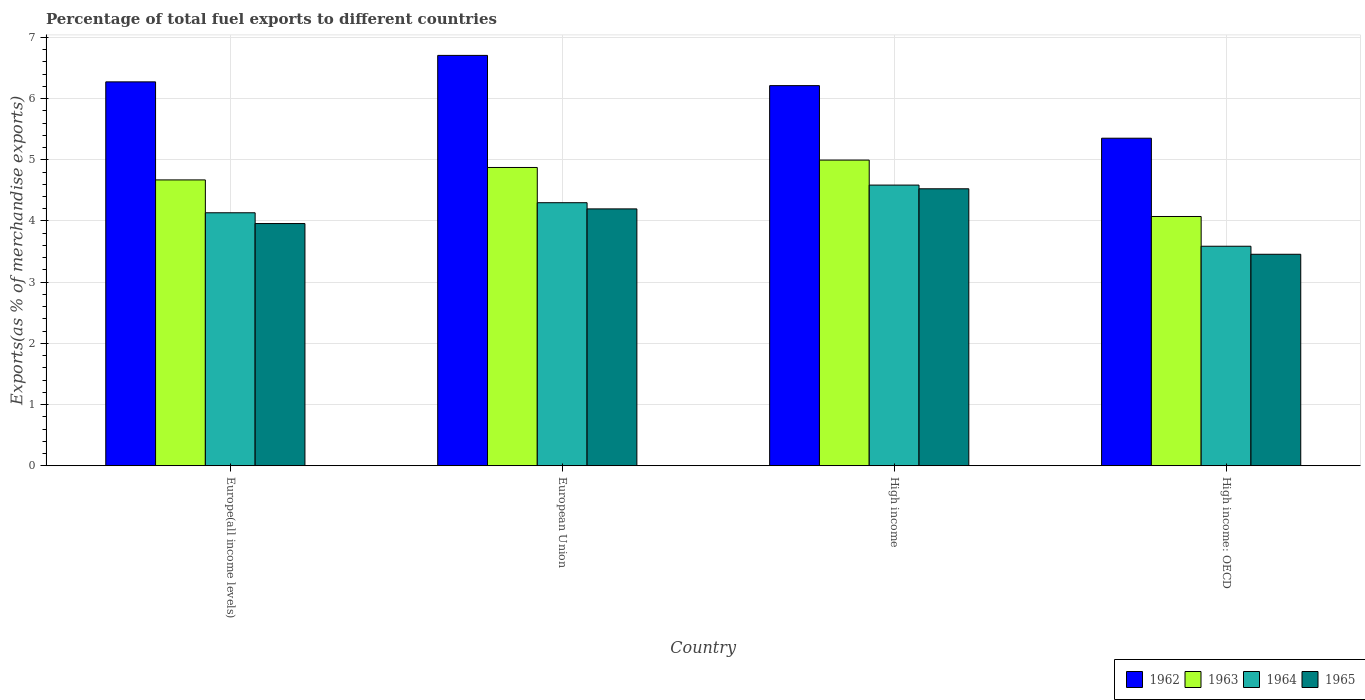What is the label of the 3rd group of bars from the left?
Offer a very short reply. High income. What is the percentage of exports to different countries in 1964 in Europe(all income levels)?
Your response must be concise. 4.13. Across all countries, what is the maximum percentage of exports to different countries in 1962?
Give a very brief answer. 6.71. Across all countries, what is the minimum percentage of exports to different countries in 1963?
Keep it short and to the point. 4.07. In which country was the percentage of exports to different countries in 1963 minimum?
Keep it short and to the point. High income: OECD. What is the total percentage of exports to different countries in 1962 in the graph?
Your response must be concise. 24.54. What is the difference between the percentage of exports to different countries in 1965 in Europe(all income levels) and that in High income: OECD?
Keep it short and to the point. 0.5. What is the difference between the percentage of exports to different countries in 1964 in High income and the percentage of exports to different countries in 1962 in European Union?
Offer a terse response. -2.12. What is the average percentage of exports to different countries in 1965 per country?
Ensure brevity in your answer.  4.03. What is the difference between the percentage of exports to different countries of/in 1964 and percentage of exports to different countries of/in 1965 in High income?
Your answer should be compact. 0.06. In how many countries, is the percentage of exports to different countries in 1962 greater than 2.8 %?
Make the answer very short. 4. What is the ratio of the percentage of exports to different countries in 1964 in High income to that in High income: OECD?
Your answer should be very brief. 1.28. What is the difference between the highest and the second highest percentage of exports to different countries in 1963?
Your response must be concise. -0.32. What is the difference between the highest and the lowest percentage of exports to different countries in 1962?
Ensure brevity in your answer.  1.35. Is the sum of the percentage of exports to different countries in 1965 in European Union and High income greater than the maximum percentage of exports to different countries in 1964 across all countries?
Make the answer very short. Yes. What does the 2nd bar from the left in High income: OECD represents?
Give a very brief answer. 1963. What does the 2nd bar from the right in High income represents?
Keep it short and to the point. 1964. Is it the case that in every country, the sum of the percentage of exports to different countries in 1963 and percentage of exports to different countries in 1962 is greater than the percentage of exports to different countries in 1964?
Provide a short and direct response. Yes. Are all the bars in the graph horizontal?
Your response must be concise. No. How many countries are there in the graph?
Provide a short and direct response. 4. Does the graph contain any zero values?
Offer a terse response. No. Does the graph contain grids?
Ensure brevity in your answer.  Yes. How many legend labels are there?
Provide a short and direct response. 4. What is the title of the graph?
Your response must be concise. Percentage of total fuel exports to different countries. What is the label or title of the X-axis?
Make the answer very short. Country. What is the label or title of the Y-axis?
Your answer should be compact. Exports(as % of merchandise exports). What is the Exports(as % of merchandise exports) of 1962 in Europe(all income levels)?
Your answer should be compact. 6.27. What is the Exports(as % of merchandise exports) in 1963 in Europe(all income levels)?
Make the answer very short. 4.67. What is the Exports(as % of merchandise exports) of 1964 in Europe(all income levels)?
Provide a succinct answer. 4.13. What is the Exports(as % of merchandise exports) in 1965 in Europe(all income levels)?
Your response must be concise. 3.96. What is the Exports(as % of merchandise exports) of 1962 in European Union?
Ensure brevity in your answer.  6.71. What is the Exports(as % of merchandise exports) of 1963 in European Union?
Give a very brief answer. 4.87. What is the Exports(as % of merchandise exports) in 1964 in European Union?
Give a very brief answer. 4.3. What is the Exports(as % of merchandise exports) of 1965 in European Union?
Offer a terse response. 4.2. What is the Exports(as % of merchandise exports) in 1962 in High income?
Your answer should be compact. 6.21. What is the Exports(as % of merchandise exports) in 1963 in High income?
Make the answer very short. 5. What is the Exports(as % of merchandise exports) of 1964 in High income?
Give a very brief answer. 4.59. What is the Exports(as % of merchandise exports) of 1965 in High income?
Give a very brief answer. 4.53. What is the Exports(as % of merchandise exports) in 1962 in High income: OECD?
Provide a succinct answer. 5.35. What is the Exports(as % of merchandise exports) in 1963 in High income: OECD?
Make the answer very short. 4.07. What is the Exports(as % of merchandise exports) of 1964 in High income: OECD?
Your answer should be very brief. 3.59. What is the Exports(as % of merchandise exports) of 1965 in High income: OECD?
Your response must be concise. 3.46. Across all countries, what is the maximum Exports(as % of merchandise exports) in 1962?
Your answer should be very brief. 6.71. Across all countries, what is the maximum Exports(as % of merchandise exports) in 1963?
Give a very brief answer. 5. Across all countries, what is the maximum Exports(as % of merchandise exports) in 1964?
Your answer should be very brief. 4.59. Across all countries, what is the maximum Exports(as % of merchandise exports) of 1965?
Keep it short and to the point. 4.53. Across all countries, what is the minimum Exports(as % of merchandise exports) of 1962?
Make the answer very short. 5.35. Across all countries, what is the minimum Exports(as % of merchandise exports) of 1963?
Offer a terse response. 4.07. Across all countries, what is the minimum Exports(as % of merchandise exports) of 1964?
Give a very brief answer. 3.59. Across all countries, what is the minimum Exports(as % of merchandise exports) of 1965?
Ensure brevity in your answer.  3.46. What is the total Exports(as % of merchandise exports) of 1962 in the graph?
Offer a very short reply. 24.54. What is the total Exports(as % of merchandise exports) in 1963 in the graph?
Make the answer very short. 18.61. What is the total Exports(as % of merchandise exports) in 1964 in the graph?
Offer a very short reply. 16.61. What is the total Exports(as % of merchandise exports) of 1965 in the graph?
Provide a short and direct response. 16.14. What is the difference between the Exports(as % of merchandise exports) in 1962 in Europe(all income levels) and that in European Union?
Provide a succinct answer. -0.43. What is the difference between the Exports(as % of merchandise exports) in 1963 in Europe(all income levels) and that in European Union?
Your response must be concise. -0.2. What is the difference between the Exports(as % of merchandise exports) of 1964 in Europe(all income levels) and that in European Union?
Provide a short and direct response. -0.16. What is the difference between the Exports(as % of merchandise exports) in 1965 in Europe(all income levels) and that in European Union?
Your answer should be compact. -0.24. What is the difference between the Exports(as % of merchandise exports) in 1962 in Europe(all income levels) and that in High income?
Keep it short and to the point. 0.06. What is the difference between the Exports(as % of merchandise exports) of 1963 in Europe(all income levels) and that in High income?
Your response must be concise. -0.32. What is the difference between the Exports(as % of merchandise exports) in 1964 in Europe(all income levels) and that in High income?
Offer a very short reply. -0.45. What is the difference between the Exports(as % of merchandise exports) of 1965 in Europe(all income levels) and that in High income?
Your response must be concise. -0.57. What is the difference between the Exports(as % of merchandise exports) in 1962 in Europe(all income levels) and that in High income: OECD?
Your answer should be very brief. 0.92. What is the difference between the Exports(as % of merchandise exports) of 1963 in Europe(all income levels) and that in High income: OECD?
Offer a very short reply. 0.6. What is the difference between the Exports(as % of merchandise exports) of 1964 in Europe(all income levels) and that in High income: OECD?
Your response must be concise. 0.55. What is the difference between the Exports(as % of merchandise exports) of 1965 in Europe(all income levels) and that in High income: OECD?
Provide a short and direct response. 0.5. What is the difference between the Exports(as % of merchandise exports) in 1962 in European Union and that in High income?
Ensure brevity in your answer.  0.49. What is the difference between the Exports(as % of merchandise exports) in 1963 in European Union and that in High income?
Make the answer very short. -0.12. What is the difference between the Exports(as % of merchandise exports) of 1964 in European Union and that in High income?
Offer a terse response. -0.29. What is the difference between the Exports(as % of merchandise exports) of 1965 in European Union and that in High income?
Make the answer very short. -0.33. What is the difference between the Exports(as % of merchandise exports) of 1962 in European Union and that in High income: OECD?
Your response must be concise. 1.35. What is the difference between the Exports(as % of merchandise exports) of 1963 in European Union and that in High income: OECD?
Your response must be concise. 0.8. What is the difference between the Exports(as % of merchandise exports) in 1964 in European Union and that in High income: OECD?
Offer a very short reply. 0.71. What is the difference between the Exports(as % of merchandise exports) in 1965 in European Union and that in High income: OECD?
Keep it short and to the point. 0.74. What is the difference between the Exports(as % of merchandise exports) of 1962 in High income and that in High income: OECD?
Provide a short and direct response. 0.86. What is the difference between the Exports(as % of merchandise exports) in 1963 in High income and that in High income: OECD?
Your answer should be compact. 0.92. What is the difference between the Exports(as % of merchandise exports) of 1964 in High income and that in High income: OECD?
Your answer should be compact. 1. What is the difference between the Exports(as % of merchandise exports) in 1965 in High income and that in High income: OECD?
Your answer should be very brief. 1.07. What is the difference between the Exports(as % of merchandise exports) in 1962 in Europe(all income levels) and the Exports(as % of merchandise exports) in 1963 in European Union?
Provide a short and direct response. 1.4. What is the difference between the Exports(as % of merchandise exports) in 1962 in Europe(all income levels) and the Exports(as % of merchandise exports) in 1964 in European Union?
Your response must be concise. 1.97. What is the difference between the Exports(as % of merchandise exports) in 1962 in Europe(all income levels) and the Exports(as % of merchandise exports) in 1965 in European Union?
Provide a short and direct response. 2.08. What is the difference between the Exports(as % of merchandise exports) in 1963 in Europe(all income levels) and the Exports(as % of merchandise exports) in 1964 in European Union?
Give a very brief answer. 0.37. What is the difference between the Exports(as % of merchandise exports) in 1963 in Europe(all income levels) and the Exports(as % of merchandise exports) in 1965 in European Union?
Offer a very short reply. 0.47. What is the difference between the Exports(as % of merchandise exports) in 1964 in Europe(all income levels) and the Exports(as % of merchandise exports) in 1965 in European Union?
Your answer should be compact. -0.06. What is the difference between the Exports(as % of merchandise exports) of 1962 in Europe(all income levels) and the Exports(as % of merchandise exports) of 1963 in High income?
Your response must be concise. 1.28. What is the difference between the Exports(as % of merchandise exports) of 1962 in Europe(all income levels) and the Exports(as % of merchandise exports) of 1964 in High income?
Offer a terse response. 1.69. What is the difference between the Exports(as % of merchandise exports) in 1962 in Europe(all income levels) and the Exports(as % of merchandise exports) in 1965 in High income?
Keep it short and to the point. 1.75. What is the difference between the Exports(as % of merchandise exports) of 1963 in Europe(all income levels) and the Exports(as % of merchandise exports) of 1964 in High income?
Make the answer very short. 0.08. What is the difference between the Exports(as % of merchandise exports) in 1963 in Europe(all income levels) and the Exports(as % of merchandise exports) in 1965 in High income?
Keep it short and to the point. 0.15. What is the difference between the Exports(as % of merchandise exports) of 1964 in Europe(all income levels) and the Exports(as % of merchandise exports) of 1965 in High income?
Offer a terse response. -0.39. What is the difference between the Exports(as % of merchandise exports) of 1962 in Europe(all income levels) and the Exports(as % of merchandise exports) of 1963 in High income: OECD?
Make the answer very short. 2.2. What is the difference between the Exports(as % of merchandise exports) of 1962 in Europe(all income levels) and the Exports(as % of merchandise exports) of 1964 in High income: OECD?
Ensure brevity in your answer.  2.69. What is the difference between the Exports(as % of merchandise exports) of 1962 in Europe(all income levels) and the Exports(as % of merchandise exports) of 1965 in High income: OECD?
Make the answer very short. 2.82. What is the difference between the Exports(as % of merchandise exports) in 1963 in Europe(all income levels) and the Exports(as % of merchandise exports) in 1964 in High income: OECD?
Offer a very short reply. 1.08. What is the difference between the Exports(as % of merchandise exports) of 1963 in Europe(all income levels) and the Exports(as % of merchandise exports) of 1965 in High income: OECD?
Provide a short and direct response. 1.22. What is the difference between the Exports(as % of merchandise exports) in 1964 in Europe(all income levels) and the Exports(as % of merchandise exports) in 1965 in High income: OECD?
Your answer should be compact. 0.68. What is the difference between the Exports(as % of merchandise exports) of 1962 in European Union and the Exports(as % of merchandise exports) of 1963 in High income?
Your response must be concise. 1.71. What is the difference between the Exports(as % of merchandise exports) in 1962 in European Union and the Exports(as % of merchandise exports) in 1964 in High income?
Provide a succinct answer. 2.12. What is the difference between the Exports(as % of merchandise exports) in 1962 in European Union and the Exports(as % of merchandise exports) in 1965 in High income?
Give a very brief answer. 2.18. What is the difference between the Exports(as % of merchandise exports) of 1963 in European Union and the Exports(as % of merchandise exports) of 1964 in High income?
Give a very brief answer. 0.29. What is the difference between the Exports(as % of merchandise exports) of 1963 in European Union and the Exports(as % of merchandise exports) of 1965 in High income?
Ensure brevity in your answer.  0.35. What is the difference between the Exports(as % of merchandise exports) of 1964 in European Union and the Exports(as % of merchandise exports) of 1965 in High income?
Your answer should be compact. -0.23. What is the difference between the Exports(as % of merchandise exports) in 1962 in European Union and the Exports(as % of merchandise exports) in 1963 in High income: OECD?
Keep it short and to the point. 2.63. What is the difference between the Exports(as % of merchandise exports) of 1962 in European Union and the Exports(as % of merchandise exports) of 1964 in High income: OECD?
Make the answer very short. 3.12. What is the difference between the Exports(as % of merchandise exports) of 1962 in European Union and the Exports(as % of merchandise exports) of 1965 in High income: OECD?
Your answer should be very brief. 3.25. What is the difference between the Exports(as % of merchandise exports) in 1963 in European Union and the Exports(as % of merchandise exports) in 1964 in High income: OECD?
Keep it short and to the point. 1.29. What is the difference between the Exports(as % of merchandise exports) of 1963 in European Union and the Exports(as % of merchandise exports) of 1965 in High income: OECD?
Offer a very short reply. 1.42. What is the difference between the Exports(as % of merchandise exports) in 1964 in European Union and the Exports(as % of merchandise exports) in 1965 in High income: OECD?
Make the answer very short. 0.84. What is the difference between the Exports(as % of merchandise exports) of 1962 in High income and the Exports(as % of merchandise exports) of 1963 in High income: OECD?
Ensure brevity in your answer.  2.14. What is the difference between the Exports(as % of merchandise exports) of 1962 in High income and the Exports(as % of merchandise exports) of 1964 in High income: OECD?
Offer a very short reply. 2.62. What is the difference between the Exports(as % of merchandise exports) in 1962 in High income and the Exports(as % of merchandise exports) in 1965 in High income: OECD?
Your answer should be compact. 2.76. What is the difference between the Exports(as % of merchandise exports) in 1963 in High income and the Exports(as % of merchandise exports) in 1964 in High income: OECD?
Make the answer very short. 1.41. What is the difference between the Exports(as % of merchandise exports) of 1963 in High income and the Exports(as % of merchandise exports) of 1965 in High income: OECD?
Ensure brevity in your answer.  1.54. What is the difference between the Exports(as % of merchandise exports) in 1964 in High income and the Exports(as % of merchandise exports) in 1965 in High income: OECD?
Your response must be concise. 1.13. What is the average Exports(as % of merchandise exports) in 1962 per country?
Your answer should be very brief. 6.14. What is the average Exports(as % of merchandise exports) of 1963 per country?
Offer a terse response. 4.65. What is the average Exports(as % of merchandise exports) in 1964 per country?
Offer a terse response. 4.15. What is the average Exports(as % of merchandise exports) in 1965 per country?
Offer a very short reply. 4.03. What is the difference between the Exports(as % of merchandise exports) in 1962 and Exports(as % of merchandise exports) in 1963 in Europe(all income levels)?
Give a very brief answer. 1.6. What is the difference between the Exports(as % of merchandise exports) in 1962 and Exports(as % of merchandise exports) in 1964 in Europe(all income levels)?
Provide a short and direct response. 2.14. What is the difference between the Exports(as % of merchandise exports) of 1962 and Exports(as % of merchandise exports) of 1965 in Europe(all income levels)?
Make the answer very short. 2.32. What is the difference between the Exports(as % of merchandise exports) of 1963 and Exports(as % of merchandise exports) of 1964 in Europe(all income levels)?
Your answer should be very brief. 0.54. What is the difference between the Exports(as % of merchandise exports) in 1963 and Exports(as % of merchandise exports) in 1965 in Europe(all income levels)?
Give a very brief answer. 0.71. What is the difference between the Exports(as % of merchandise exports) of 1964 and Exports(as % of merchandise exports) of 1965 in Europe(all income levels)?
Your answer should be very brief. 0.18. What is the difference between the Exports(as % of merchandise exports) in 1962 and Exports(as % of merchandise exports) in 1963 in European Union?
Make the answer very short. 1.83. What is the difference between the Exports(as % of merchandise exports) of 1962 and Exports(as % of merchandise exports) of 1964 in European Union?
Offer a terse response. 2.41. What is the difference between the Exports(as % of merchandise exports) in 1962 and Exports(as % of merchandise exports) in 1965 in European Union?
Your answer should be very brief. 2.51. What is the difference between the Exports(as % of merchandise exports) in 1963 and Exports(as % of merchandise exports) in 1964 in European Union?
Offer a very short reply. 0.58. What is the difference between the Exports(as % of merchandise exports) in 1963 and Exports(as % of merchandise exports) in 1965 in European Union?
Offer a very short reply. 0.68. What is the difference between the Exports(as % of merchandise exports) in 1964 and Exports(as % of merchandise exports) in 1965 in European Union?
Your answer should be compact. 0.1. What is the difference between the Exports(as % of merchandise exports) in 1962 and Exports(as % of merchandise exports) in 1963 in High income?
Provide a succinct answer. 1.22. What is the difference between the Exports(as % of merchandise exports) of 1962 and Exports(as % of merchandise exports) of 1964 in High income?
Make the answer very short. 1.63. What is the difference between the Exports(as % of merchandise exports) in 1962 and Exports(as % of merchandise exports) in 1965 in High income?
Make the answer very short. 1.69. What is the difference between the Exports(as % of merchandise exports) in 1963 and Exports(as % of merchandise exports) in 1964 in High income?
Make the answer very short. 0.41. What is the difference between the Exports(as % of merchandise exports) of 1963 and Exports(as % of merchandise exports) of 1965 in High income?
Ensure brevity in your answer.  0.47. What is the difference between the Exports(as % of merchandise exports) in 1964 and Exports(as % of merchandise exports) in 1965 in High income?
Your answer should be compact. 0.06. What is the difference between the Exports(as % of merchandise exports) in 1962 and Exports(as % of merchandise exports) in 1963 in High income: OECD?
Ensure brevity in your answer.  1.28. What is the difference between the Exports(as % of merchandise exports) in 1962 and Exports(as % of merchandise exports) in 1964 in High income: OECD?
Your response must be concise. 1.77. What is the difference between the Exports(as % of merchandise exports) of 1962 and Exports(as % of merchandise exports) of 1965 in High income: OECD?
Make the answer very short. 1.9. What is the difference between the Exports(as % of merchandise exports) of 1963 and Exports(as % of merchandise exports) of 1964 in High income: OECD?
Keep it short and to the point. 0.49. What is the difference between the Exports(as % of merchandise exports) of 1963 and Exports(as % of merchandise exports) of 1965 in High income: OECD?
Your response must be concise. 0.62. What is the difference between the Exports(as % of merchandise exports) in 1964 and Exports(as % of merchandise exports) in 1965 in High income: OECD?
Your answer should be very brief. 0.13. What is the ratio of the Exports(as % of merchandise exports) in 1962 in Europe(all income levels) to that in European Union?
Provide a short and direct response. 0.94. What is the ratio of the Exports(as % of merchandise exports) of 1963 in Europe(all income levels) to that in European Union?
Provide a short and direct response. 0.96. What is the ratio of the Exports(as % of merchandise exports) in 1964 in Europe(all income levels) to that in European Union?
Provide a succinct answer. 0.96. What is the ratio of the Exports(as % of merchandise exports) in 1965 in Europe(all income levels) to that in European Union?
Provide a succinct answer. 0.94. What is the ratio of the Exports(as % of merchandise exports) of 1962 in Europe(all income levels) to that in High income?
Keep it short and to the point. 1.01. What is the ratio of the Exports(as % of merchandise exports) of 1963 in Europe(all income levels) to that in High income?
Offer a very short reply. 0.94. What is the ratio of the Exports(as % of merchandise exports) of 1964 in Europe(all income levels) to that in High income?
Offer a terse response. 0.9. What is the ratio of the Exports(as % of merchandise exports) in 1965 in Europe(all income levels) to that in High income?
Offer a terse response. 0.87. What is the ratio of the Exports(as % of merchandise exports) in 1962 in Europe(all income levels) to that in High income: OECD?
Your answer should be very brief. 1.17. What is the ratio of the Exports(as % of merchandise exports) in 1963 in Europe(all income levels) to that in High income: OECD?
Offer a very short reply. 1.15. What is the ratio of the Exports(as % of merchandise exports) in 1964 in Europe(all income levels) to that in High income: OECD?
Provide a succinct answer. 1.15. What is the ratio of the Exports(as % of merchandise exports) of 1965 in Europe(all income levels) to that in High income: OECD?
Give a very brief answer. 1.15. What is the ratio of the Exports(as % of merchandise exports) of 1962 in European Union to that in High income?
Keep it short and to the point. 1.08. What is the ratio of the Exports(as % of merchandise exports) in 1963 in European Union to that in High income?
Your answer should be very brief. 0.98. What is the ratio of the Exports(as % of merchandise exports) of 1964 in European Union to that in High income?
Your answer should be very brief. 0.94. What is the ratio of the Exports(as % of merchandise exports) of 1965 in European Union to that in High income?
Your answer should be very brief. 0.93. What is the ratio of the Exports(as % of merchandise exports) of 1962 in European Union to that in High income: OECD?
Keep it short and to the point. 1.25. What is the ratio of the Exports(as % of merchandise exports) of 1963 in European Union to that in High income: OECD?
Provide a succinct answer. 1.2. What is the ratio of the Exports(as % of merchandise exports) of 1964 in European Union to that in High income: OECD?
Ensure brevity in your answer.  1.2. What is the ratio of the Exports(as % of merchandise exports) of 1965 in European Union to that in High income: OECD?
Provide a succinct answer. 1.21. What is the ratio of the Exports(as % of merchandise exports) of 1962 in High income to that in High income: OECD?
Provide a succinct answer. 1.16. What is the ratio of the Exports(as % of merchandise exports) in 1963 in High income to that in High income: OECD?
Your answer should be compact. 1.23. What is the ratio of the Exports(as % of merchandise exports) of 1964 in High income to that in High income: OECD?
Your answer should be very brief. 1.28. What is the ratio of the Exports(as % of merchandise exports) in 1965 in High income to that in High income: OECD?
Offer a terse response. 1.31. What is the difference between the highest and the second highest Exports(as % of merchandise exports) of 1962?
Offer a very short reply. 0.43. What is the difference between the highest and the second highest Exports(as % of merchandise exports) of 1963?
Provide a short and direct response. 0.12. What is the difference between the highest and the second highest Exports(as % of merchandise exports) of 1964?
Give a very brief answer. 0.29. What is the difference between the highest and the second highest Exports(as % of merchandise exports) of 1965?
Provide a succinct answer. 0.33. What is the difference between the highest and the lowest Exports(as % of merchandise exports) of 1962?
Your answer should be very brief. 1.35. What is the difference between the highest and the lowest Exports(as % of merchandise exports) of 1963?
Offer a terse response. 0.92. What is the difference between the highest and the lowest Exports(as % of merchandise exports) in 1965?
Ensure brevity in your answer.  1.07. 